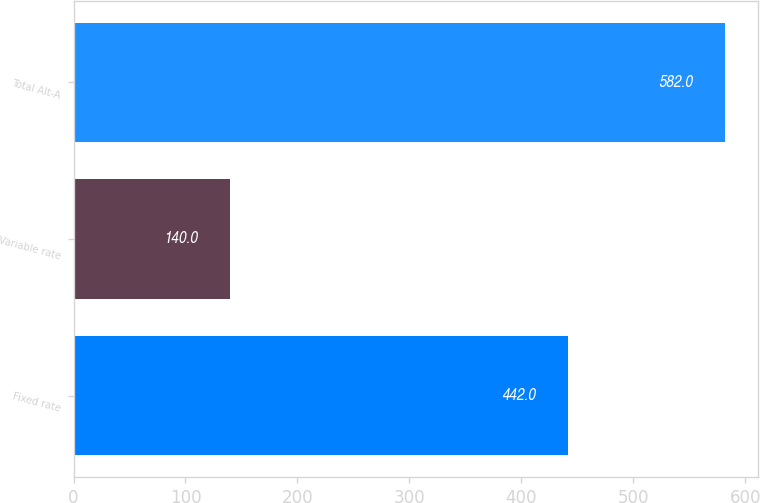<chart> <loc_0><loc_0><loc_500><loc_500><bar_chart><fcel>Fixed rate<fcel>Variable rate<fcel>Total Alt-A<nl><fcel>442<fcel>140<fcel>582<nl></chart> 